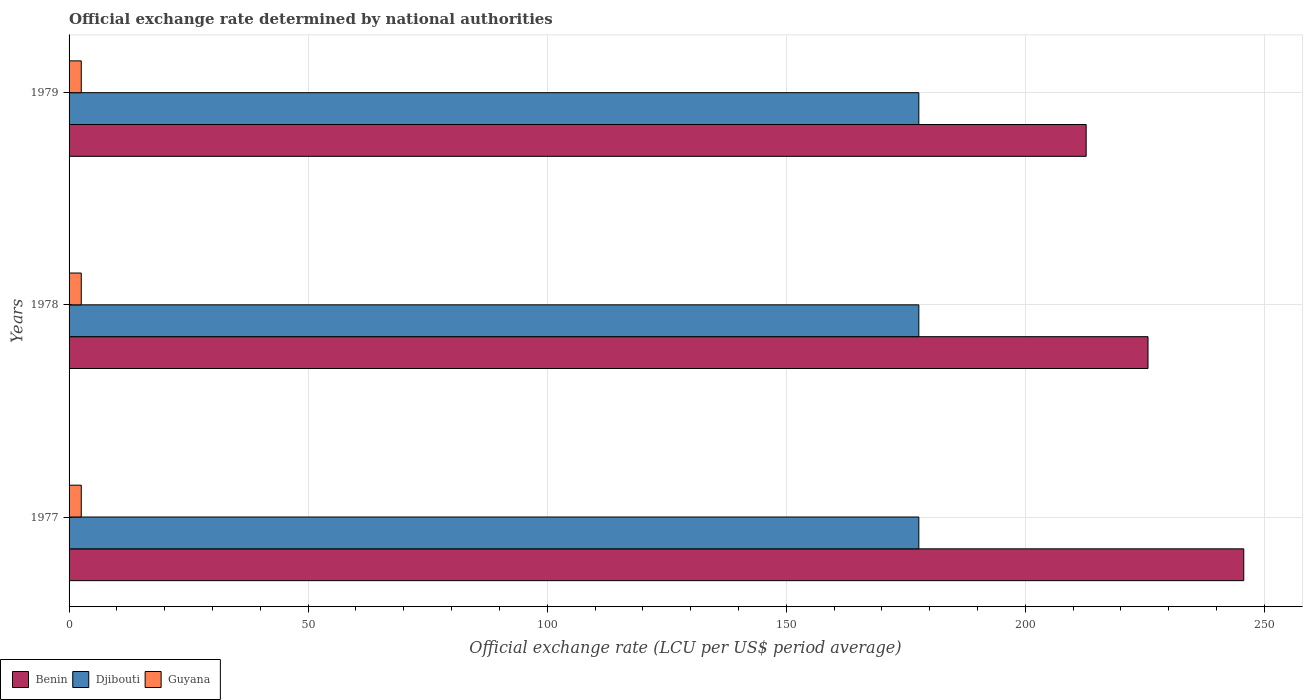How many different coloured bars are there?
Make the answer very short. 3. How many groups of bars are there?
Provide a succinct answer. 3. Are the number of bars on each tick of the Y-axis equal?
Provide a short and direct response. Yes. What is the label of the 1st group of bars from the top?
Give a very brief answer. 1979. What is the official exchange rate in Benin in 1978?
Keep it short and to the point. 225.66. Across all years, what is the maximum official exchange rate in Djibouti?
Your response must be concise. 177.72. Across all years, what is the minimum official exchange rate in Guyana?
Give a very brief answer. 2.55. In which year was the official exchange rate in Djibouti maximum?
Make the answer very short. 1977. In which year was the official exchange rate in Guyana minimum?
Give a very brief answer. 1977. What is the total official exchange rate in Guyana in the graph?
Make the answer very short. 7.65. What is the difference between the official exchange rate in Benin in 1978 and that in 1979?
Your answer should be compact. 12.93. What is the difference between the official exchange rate in Djibouti in 1979 and the official exchange rate in Benin in 1978?
Your response must be concise. -47.93. What is the average official exchange rate in Djibouti per year?
Your answer should be compact. 177.72. In the year 1978, what is the difference between the official exchange rate in Djibouti and official exchange rate in Guyana?
Provide a succinct answer. 175.17. In how many years, is the official exchange rate in Benin greater than 70 LCU?
Provide a succinct answer. 3. What is the difference between the highest and the second highest official exchange rate in Djibouti?
Provide a short and direct response. 0. In how many years, is the official exchange rate in Guyana greater than the average official exchange rate in Guyana taken over all years?
Ensure brevity in your answer.  0. What does the 1st bar from the top in 1978 represents?
Your answer should be very brief. Guyana. What does the 2nd bar from the bottom in 1977 represents?
Your response must be concise. Djibouti. How many bars are there?
Keep it short and to the point. 9. What is the difference between two consecutive major ticks on the X-axis?
Your answer should be compact. 50. Are the values on the major ticks of X-axis written in scientific E-notation?
Keep it short and to the point. No. Does the graph contain any zero values?
Offer a very short reply. No. Where does the legend appear in the graph?
Ensure brevity in your answer.  Bottom left. What is the title of the graph?
Ensure brevity in your answer.  Official exchange rate determined by national authorities. What is the label or title of the X-axis?
Give a very brief answer. Official exchange rate (LCU per US$ period average). What is the Official exchange rate (LCU per US$ period average) of Benin in 1977?
Keep it short and to the point. 245.68. What is the Official exchange rate (LCU per US$ period average) in Djibouti in 1977?
Provide a short and direct response. 177.72. What is the Official exchange rate (LCU per US$ period average) in Guyana in 1977?
Keep it short and to the point. 2.55. What is the Official exchange rate (LCU per US$ period average) in Benin in 1978?
Give a very brief answer. 225.66. What is the Official exchange rate (LCU per US$ period average) of Djibouti in 1978?
Offer a very short reply. 177.72. What is the Official exchange rate (LCU per US$ period average) in Guyana in 1978?
Your answer should be very brief. 2.55. What is the Official exchange rate (LCU per US$ period average) in Benin in 1979?
Offer a very short reply. 212.72. What is the Official exchange rate (LCU per US$ period average) of Djibouti in 1979?
Make the answer very short. 177.72. What is the Official exchange rate (LCU per US$ period average) of Guyana in 1979?
Keep it short and to the point. 2.55. Across all years, what is the maximum Official exchange rate (LCU per US$ period average) of Benin?
Offer a terse response. 245.68. Across all years, what is the maximum Official exchange rate (LCU per US$ period average) in Djibouti?
Give a very brief answer. 177.72. Across all years, what is the maximum Official exchange rate (LCU per US$ period average) in Guyana?
Offer a terse response. 2.55. Across all years, what is the minimum Official exchange rate (LCU per US$ period average) of Benin?
Offer a very short reply. 212.72. Across all years, what is the minimum Official exchange rate (LCU per US$ period average) of Djibouti?
Offer a terse response. 177.72. Across all years, what is the minimum Official exchange rate (LCU per US$ period average) of Guyana?
Keep it short and to the point. 2.55. What is the total Official exchange rate (LCU per US$ period average) in Benin in the graph?
Your response must be concise. 684.06. What is the total Official exchange rate (LCU per US$ period average) in Djibouti in the graph?
Make the answer very short. 533.16. What is the total Official exchange rate (LCU per US$ period average) of Guyana in the graph?
Offer a terse response. 7.65. What is the difference between the Official exchange rate (LCU per US$ period average) in Benin in 1977 and that in 1978?
Give a very brief answer. 20.02. What is the difference between the Official exchange rate (LCU per US$ period average) of Djibouti in 1977 and that in 1978?
Provide a short and direct response. 0. What is the difference between the Official exchange rate (LCU per US$ period average) in Benin in 1977 and that in 1979?
Your answer should be very brief. 32.96. What is the difference between the Official exchange rate (LCU per US$ period average) in Benin in 1978 and that in 1979?
Your answer should be very brief. 12.93. What is the difference between the Official exchange rate (LCU per US$ period average) of Djibouti in 1978 and that in 1979?
Your answer should be compact. 0. What is the difference between the Official exchange rate (LCU per US$ period average) of Guyana in 1978 and that in 1979?
Your answer should be very brief. 0. What is the difference between the Official exchange rate (LCU per US$ period average) in Benin in 1977 and the Official exchange rate (LCU per US$ period average) in Djibouti in 1978?
Offer a very short reply. 67.96. What is the difference between the Official exchange rate (LCU per US$ period average) in Benin in 1977 and the Official exchange rate (LCU per US$ period average) in Guyana in 1978?
Your answer should be compact. 243.13. What is the difference between the Official exchange rate (LCU per US$ period average) in Djibouti in 1977 and the Official exchange rate (LCU per US$ period average) in Guyana in 1978?
Provide a short and direct response. 175.17. What is the difference between the Official exchange rate (LCU per US$ period average) of Benin in 1977 and the Official exchange rate (LCU per US$ period average) of Djibouti in 1979?
Offer a terse response. 67.96. What is the difference between the Official exchange rate (LCU per US$ period average) in Benin in 1977 and the Official exchange rate (LCU per US$ period average) in Guyana in 1979?
Your response must be concise. 243.13. What is the difference between the Official exchange rate (LCU per US$ period average) of Djibouti in 1977 and the Official exchange rate (LCU per US$ period average) of Guyana in 1979?
Offer a very short reply. 175.17. What is the difference between the Official exchange rate (LCU per US$ period average) in Benin in 1978 and the Official exchange rate (LCU per US$ period average) in Djibouti in 1979?
Your response must be concise. 47.93. What is the difference between the Official exchange rate (LCU per US$ period average) in Benin in 1978 and the Official exchange rate (LCU per US$ period average) in Guyana in 1979?
Keep it short and to the point. 223.11. What is the difference between the Official exchange rate (LCU per US$ period average) of Djibouti in 1978 and the Official exchange rate (LCU per US$ period average) of Guyana in 1979?
Offer a terse response. 175.17. What is the average Official exchange rate (LCU per US$ period average) in Benin per year?
Your answer should be very brief. 228.02. What is the average Official exchange rate (LCU per US$ period average) of Djibouti per year?
Offer a terse response. 177.72. What is the average Official exchange rate (LCU per US$ period average) in Guyana per year?
Make the answer very short. 2.55. In the year 1977, what is the difference between the Official exchange rate (LCU per US$ period average) in Benin and Official exchange rate (LCU per US$ period average) in Djibouti?
Offer a terse response. 67.96. In the year 1977, what is the difference between the Official exchange rate (LCU per US$ period average) in Benin and Official exchange rate (LCU per US$ period average) in Guyana?
Offer a terse response. 243.13. In the year 1977, what is the difference between the Official exchange rate (LCU per US$ period average) of Djibouti and Official exchange rate (LCU per US$ period average) of Guyana?
Give a very brief answer. 175.17. In the year 1978, what is the difference between the Official exchange rate (LCU per US$ period average) in Benin and Official exchange rate (LCU per US$ period average) in Djibouti?
Provide a short and direct response. 47.93. In the year 1978, what is the difference between the Official exchange rate (LCU per US$ period average) of Benin and Official exchange rate (LCU per US$ period average) of Guyana?
Ensure brevity in your answer.  223.11. In the year 1978, what is the difference between the Official exchange rate (LCU per US$ period average) of Djibouti and Official exchange rate (LCU per US$ period average) of Guyana?
Offer a terse response. 175.17. In the year 1979, what is the difference between the Official exchange rate (LCU per US$ period average) in Benin and Official exchange rate (LCU per US$ period average) in Djibouti?
Offer a terse response. 35. In the year 1979, what is the difference between the Official exchange rate (LCU per US$ period average) in Benin and Official exchange rate (LCU per US$ period average) in Guyana?
Give a very brief answer. 210.17. In the year 1979, what is the difference between the Official exchange rate (LCU per US$ period average) in Djibouti and Official exchange rate (LCU per US$ period average) in Guyana?
Offer a terse response. 175.17. What is the ratio of the Official exchange rate (LCU per US$ period average) of Benin in 1977 to that in 1978?
Keep it short and to the point. 1.09. What is the ratio of the Official exchange rate (LCU per US$ period average) in Benin in 1977 to that in 1979?
Offer a very short reply. 1.15. What is the ratio of the Official exchange rate (LCU per US$ period average) in Benin in 1978 to that in 1979?
Provide a short and direct response. 1.06. What is the difference between the highest and the second highest Official exchange rate (LCU per US$ period average) in Benin?
Provide a succinct answer. 20.02. What is the difference between the highest and the second highest Official exchange rate (LCU per US$ period average) of Djibouti?
Keep it short and to the point. 0. What is the difference between the highest and the lowest Official exchange rate (LCU per US$ period average) in Benin?
Give a very brief answer. 32.96. What is the difference between the highest and the lowest Official exchange rate (LCU per US$ period average) of Djibouti?
Offer a terse response. 0. 